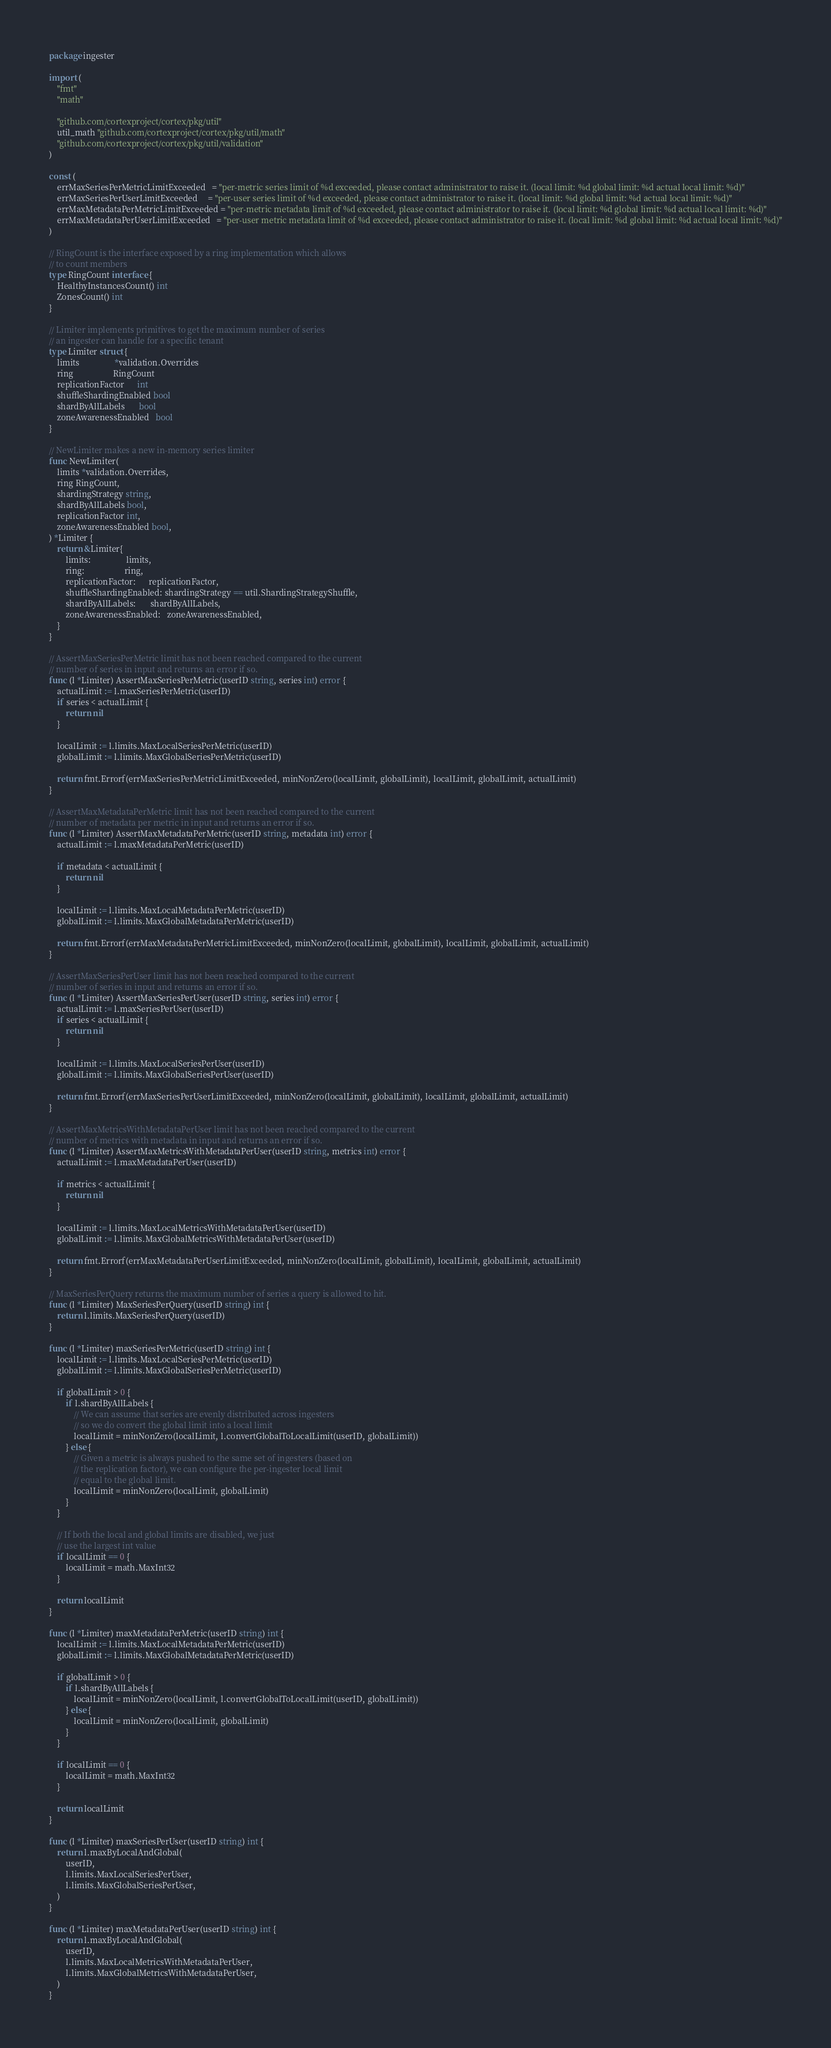<code> <loc_0><loc_0><loc_500><loc_500><_Go_>package ingester

import (
	"fmt"
	"math"

	"github.com/cortexproject/cortex/pkg/util"
	util_math "github.com/cortexproject/cortex/pkg/util/math"
	"github.com/cortexproject/cortex/pkg/util/validation"
)

const (
	errMaxSeriesPerMetricLimitExceeded   = "per-metric series limit of %d exceeded, please contact administrator to raise it. (local limit: %d global limit: %d actual local limit: %d)"
	errMaxSeriesPerUserLimitExceeded     = "per-user series limit of %d exceeded, please contact administrator to raise it. (local limit: %d global limit: %d actual local limit: %d)"
	errMaxMetadataPerMetricLimitExceeded = "per-metric metadata limit of %d exceeded, please contact administrator to raise it. (local limit: %d global limit: %d actual local limit: %d)"
	errMaxMetadataPerUserLimitExceeded   = "per-user metric metadata limit of %d exceeded, please contact administrator to raise it. (local limit: %d global limit: %d actual local limit: %d)"
)

// RingCount is the interface exposed by a ring implementation which allows
// to count members
type RingCount interface {
	HealthyInstancesCount() int
	ZonesCount() int
}

// Limiter implements primitives to get the maximum number of series
// an ingester can handle for a specific tenant
type Limiter struct {
	limits                 *validation.Overrides
	ring                   RingCount
	replicationFactor      int
	shuffleShardingEnabled bool
	shardByAllLabels       bool
	zoneAwarenessEnabled   bool
}

// NewLimiter makes a new in-memory series limiter
func NewLimiter(
	limits *validation.Overrides,
	ring RingCount,
	shardingStrategy string,
	shardByAllLabels bool,
	replicationFactor int,
	zoneAwarenessEnabled bool,
) *Limiter {
	return &Limiter{
		limits:                 limits,
		ring:                   ring,
		replicationFactor:      replicationFactor,
		shuffleShardingEnabled: shardingStrategy == util.ShardingStrategyShuffle,
		shardByAllLabels:       shardByAllLabels,
		zoneAwarenessEnabled:   zoneAwarenessEnabled,
	}
}

// AssertMaxSeriesPerMetric limit has not been reached compared to the current
// number of series in input and returns an error if so.
func (l *Limiter) AssertMaxSeriesPerMetric(userID string, series int) error {
	actualLimit := l.maxSeriesPerMetric(userID)
	if series < actualLimit {
		return nil
	}

	localLimit := l.limits.MaxLocalSeriesPerMetric(userID)
	globalLimit := l.limits.MaxGlobalSeriesPerMetric(userID)

	return fmt.Errorf(errMaxSeriesPerMetricLimitExceeded, minNonZero(localLimit, globalLimit), localLimit, globalLimit, actualLimit)
}

// AssertMaxMetadataPerMetric limit has not been reached compared to the current
// number of metadata per metric in input and returns an error if so.
func (l *Limiter) AssertMaxMetadataPerMetric(userID string, metadata int) error {
	actualLimit := l.maxMetadataPerMetric(userID)

	if metadata < actualLimit {
		return nil
	}

	localLimit := l.limits.MaxLocalMetadataPerMetric(userID)
	globalLimit := l.limits.MaxGlobalMetadataPerMetric(userID)

	return fmt.Errorf(errMaxMetadataPerMetricLimitExceeded, minNonZero(localLimit, globalLimit), localLimit, globalLimit, actualLimit)
}

// AssertMaxSeriesPerUser limit has not been reached compared to the current
// number of series in input and returns an error if so.
func (l *Limiter) AssertMaxSeriesPerUser(userID string, series int) error {
	actualLimit := l.maxSeriesPerUser(userID)
	if series < actualLimit {
		return nil
	}

	localLimit := l.limits.MaxLocalSeriesPerUser(userID)
	globalLimit := l.limits.MaxGlobalSeriesPerUser(userID)

	return fmt.Errorf(errMaxSeriesPerUserLimitExceeded, minNonZero(localLimit, globalLimit), localLimit, globalLimit, actualLimit)
}

// AssertMaxMetricsWithMetadataPerUser limit has not been reached compared to the current
// number of metrics with metadata in input and returns an error if so.
func (l *Limiter) AssertMaxMetricsWithMetadataPerUser(userID string, metrics int) error {
	actualLimit := l.maxMetadataPerUser(userID)

	if metrics < actualLimit {
		return nil
	}

	localLimit := l.limits.MaxLocalMetricsWithMetadataPerUser(userID)
	globalLimit := l.limits.MaxGlobalMetricsWithMetadataPerUser(userID)

	return fmt.Errorf(errMaxMetadataPerUserLimitExceeded, minNonZero(localLimit, globalLimit), localLimit, globalLimit, actualLimit)
}

// MaxSeriesPerQuery returns the maximum number of series a query is allowed to hit.
func (l *Limiter) MaxSeriesPerQuery(userID string) int {
	return l.limits.MaxSeriesPerQuery(userID)
}

func (l *Limiter) maxSeriesPerMetric(userID string) int {
	localLimit := l.limits.MaxLocalSeriesPerMetric(userID)
	globalLimit := l.limits.MaxGlobalSeriesPerMetric(userID)

	if globalLimit > 0 {
		if l.shardByAllLabels {
			// We can assume that series are evenly distributed across ingesters
			// so we do convert the global limit into a local limit
			localLimit = minNonZero(localLimit, l.convertGlobalToLocalLimit(userID, globalLimit))
		} else {
			// Given a metric is always pushed to the same set of ingesters (based on
			// the replication factor), we can configure the per-ingester local limit
			// equal to the global limit.
			localLimit = minNonZero(localLimit, globalLimit)
		}
	}

	// If both the local and global limits are disabled, we just
	// use the largest int value
	if localLimit == 0 {
		localLimit = math.MaxInt32
	}

	return localLimit
}

func (l *Limiter) maxMetadataPerMetric(userID string) int {
	localLimit := l.limits.MaxLocalMetadataPerMetric(userID)
	globalLimit := l.limits.MaxGlobalMetadataPerMetric(userID)

	if globalLimit > 0 {
		if l.shardByAllLabels {
			localLimit = minNonZero(localLimit, l.convertGlobalToLocalLimit(userID, globalLimit))
		} else {
			localLimit = minNonZero(localLimit, globalLimit)
		}
	}

	if localLimit == 0 {
		localLimit = math.MaxInt32
	}

	return localLimit
}

func (l *Limiter) maxSeriesPerUser(userID string) int {
	return l.maxByLocalAndGlobal(
		userID,
		l.limits.MaxLocalSeriesPerUser,
		l.limits.MaxGlobalSeriesPerUser,
	)
}

func (l *Limiter) maxMetadataPerUser(userID string) int {
	return l.maxByLocalAndGlobal(
		userID,
		l.limits.MaxLocalMetricsWithMetadataPerUser,
		l.limits.MaxGlobalMetricsWithMetadataPerUser,
	)
}
</code> 